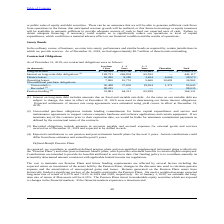According to Consolidated Communications Holdings's financial document, On which debt is the interest on long-term debt is charged? Interest on long-term debt includes amounts due on fixed and variable rate debt. The document states: "(1) Interest on long-term debt includes amounts due on fixed and variable rate debt. As the rates on our variable debt are..." Also, What was the total long term debt? According to the financial document, $ 2,269,713 (in thousands). The relevant text states: "Long-term debt $ 18,350 $ 521,700 $ 1,729,663 $ — $ 2,269,713..." Also, What was the total finance leases? According to the financial document, 28,573 (in thousands). The relevant text states: "Finance leases 10,280 8,285 3,404 6,604 28,573..." Also, can you calculate: What was the change between the long-term debt 1-3 years and 3-5 years? Based on the calculation: 1,729,663 - 521,700, the result is 1207963 (in thousands). This is based on the information: "Long-term debt $ 18,350 $ 521,700 $ 1,729,663 $ — $ 2,269,713 Long-term debt $ 18,350 $ 521,700 $ 1,729,663 $ — $ 2,269,713..." The key data points involved are: 1,729,663, 521,700. Also, can you calculate: What was the change between the finance leases from 3-5 years and thereafter? Based on the calculation: 6,604 - 3,404, the result is 3200 (in thousands). This is based on the information: "Finance leases 10,280 8,285 3,404 6,604 28,573 Finance leases 10,280 8,285 3,404 6,604 28,573..." The key data points involved are: 3,404, 6,604. Also, can you calculate: What was the change in pension funding between 1-3 years and 3-5 years? Based on the calculation: 65,959 - 64,311, the result is 1648 (in thousands). This is based on the information: "Pension funding (4) 33,861 64,311 65,959 — 164,131 Pension funding (4) 33,861 64,311 65,959 — 164,131..." The key data points involved are: 64,311, 65,959. 